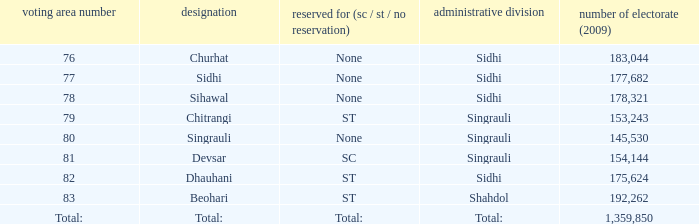What is Beohari's highest number of electorates? 192262.0. 